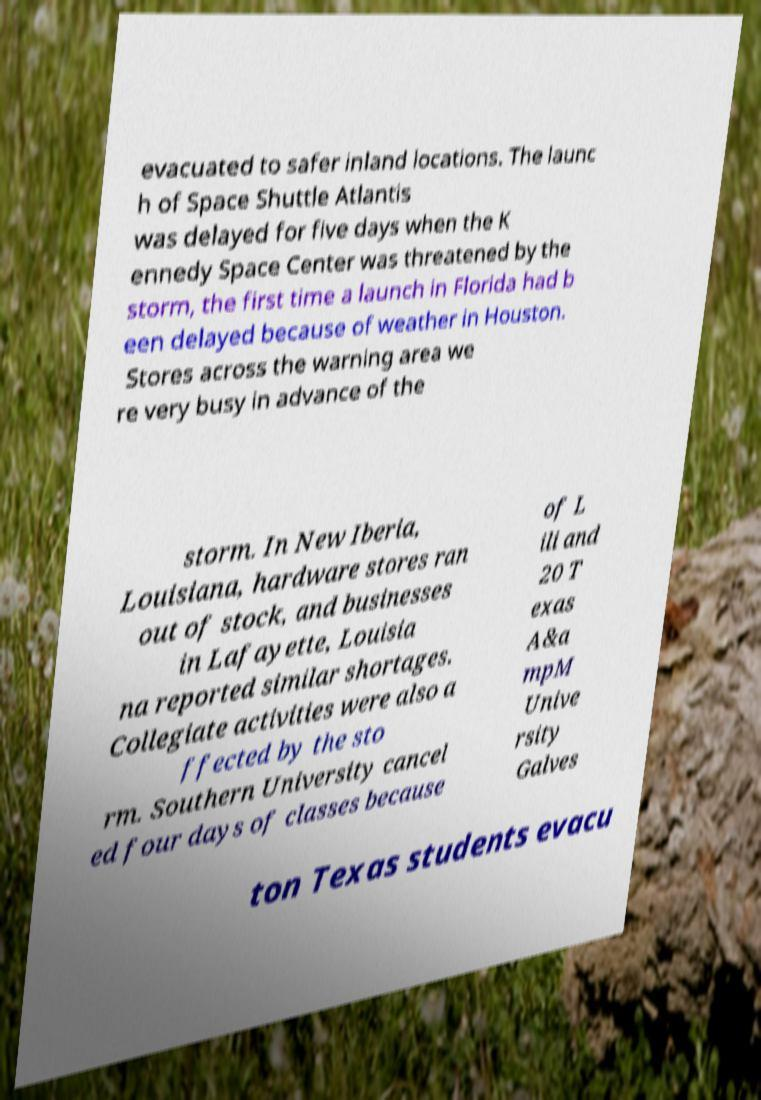There's text embedded in this image that I need extracted. Can you transcribe it verbatim? evacuated to safer inland locations. The launc h of Space Shuttle Atlantis was delayed for five days when the K ennedy Space Center was threatened by the storm, the first time a launch in Florida had b een delayed because of weather in Houston. Stores across the warning area we re very busy in advance of the storm. In New Iberia, Louisiana, hardware stores ran out of stock, and businesses in Lafayette, Louisia na reported similar shortages. Collegiate activities were also a ffected by the sto rm. Southern University cancel ed four days of classes because of L ili and 20 T exas A&a mpM Unive rsity Galves ton Texas students evacu 